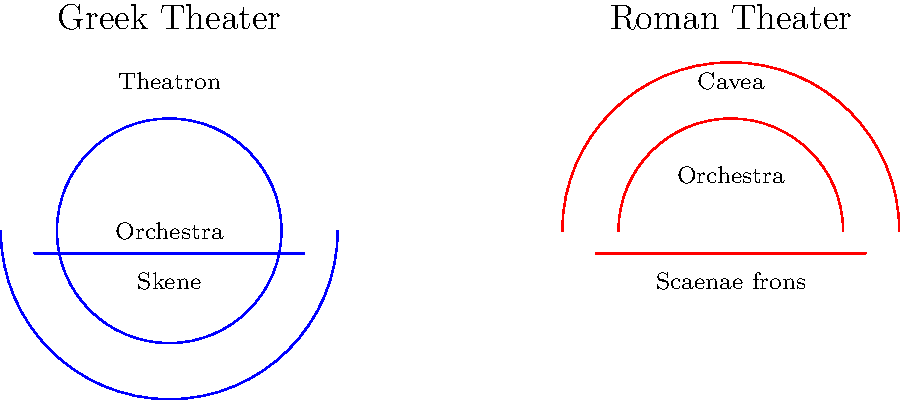Analyze the diagram comparing Greek and Roman theater layouts. Identify two key structural differences between these layouts and explain how these differences might reflect the evolution of theatrical practices from Greek to Roman times. To answer this question, we need to examine the structural differences between Greek and Roman theaters and consider their implications for theatrical practices:

1. Shape of the orchestra:
   - Greek: The orchestra is a full circle.
   - Roman: The orchestra is a semi-circle.
   This change reflects a shift in the importance of the chorus. In Greek theater, the chorus played a central role, requiring a larger performance space. The reduced Roman orchestra suggests a diminished role for the chorus and more focus on the actors.

2. Audience seating area:
   - Greek: The theatron forms an arc greater than 180 degrees, wrapping around more than half of the orchestra.
   - Roman: The cavea forms a precise semi-circle, aligning with the orchestra's curve.
   This change indicates a more focused viewing experience in Roman theaters, with all spectators facing the stage directly. It also suggests a greater emphasis on the visual aspects of performance, particularly the elaborate scaenae frons (stage building) in Roman theaters.

3. Stage building:
   - Greek: The skene is a simple, straight structure behind the orchestra.
   - Roman: The scaenae frons is more prominent and elaborate, forming the backdrop of the performance space.
   This evolution points to a shift in staging practices, with Roman theater placing more emphasis on spectacle and visual elements, possibly including more complex sets and machinery.

These structural changes reflect the evolution of theatrical practices from Greek to Roman times, showing a transition from a chorus-centered, ritualistic performance style to a more actor-focused, spectacular form of entertainment.
Answer: Orchestra shape (full circle to semi-circle) and stage prominence (simple skene to elaborate scaenae frons), reflecting shift from chorus-centered to actor-focused performances. 